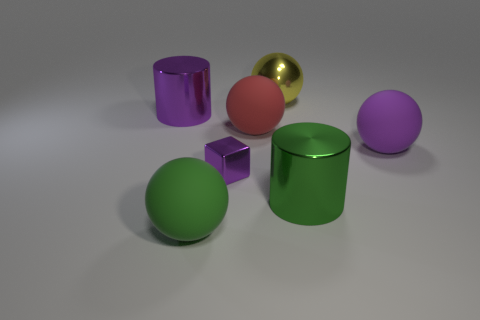If these objects were part of a physics simulation, what could happen if the table was tilted? If the table in the image was tilted, the objects, which appear to be freely resting on the surface, would likely slide or roll off the table due to gravity. Spheres would roll, while the cylinder and cube might slide or tumble depending on the angle of the tilt. 